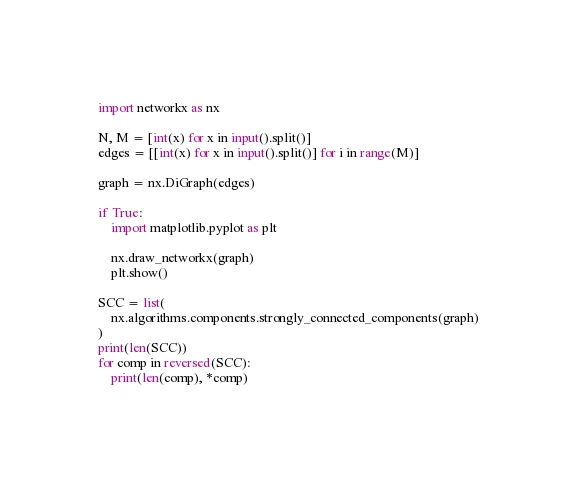Convert code to text. <code><loc_0><loc_0><loc_500><loc_500><_Python_>import networkx as nx

N, M = [int(x) for x in input().split()]
edges = [[int(x) for x in input().split()] for i in range(M)]

graph = nx.DiGraph(edges)

if True:
    import matplotlib.pyplot as plt

    nx.draw_networkx(graph)
    plt.show()

SCC = list(
    nx.algorithms.components.strongly_connected_components(graph)
)
print(len(SCC))
for comp in reversed(SCC):
    print(len(comp), *comp)
</code> 